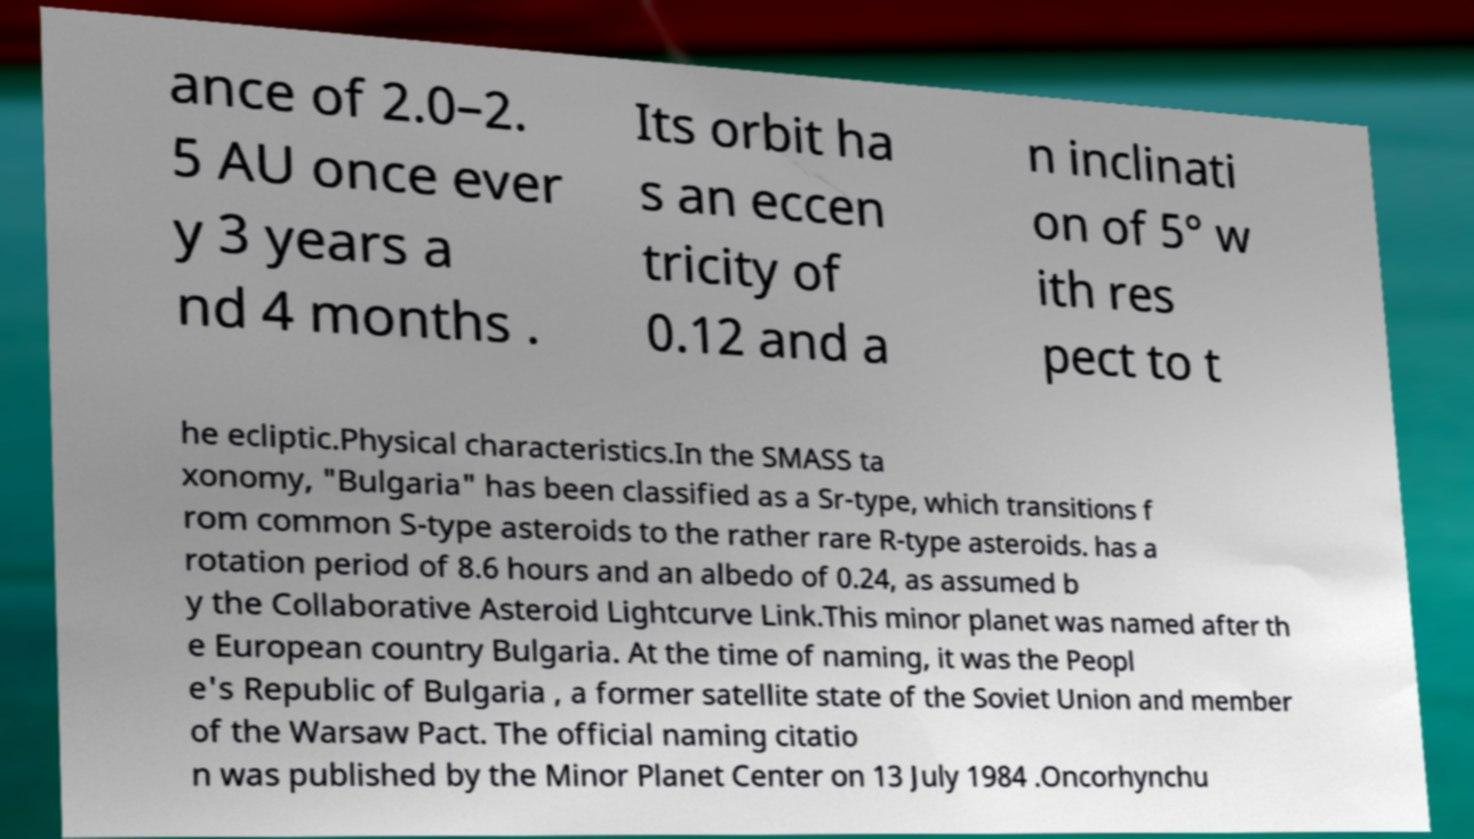Please read and relay the text visible in this image. What does it say? ance of 2.0–2. 5 AU once ever y 3 years a nd 4 months . Its orbit ha s an eccen tricity of 0.12 and a n inclinati on of 5° w ith res pect to t he ecliptic.Physical characteristics.In the SMASS ta xonomy, "Bulgaria" has been classified as a Sr-type, which transitions f rom common S-type asteroids to the rather rare R-type asteroids. has a rotation period of 8.6 hours and an albedo of 0.24, as assumed b y the Collaborative Asteroid Lightcurve Link.This minor planet was named after th e European country Bulgaria. At the time of naming, it was the Peopl e's Republic of Bulgaria , a former satellite state of the Soviet Union and member of the Warsaw Pact. The official naming citatio n was published by the Minor Planet Center on 13 July 1984 .Oncorhynchu 